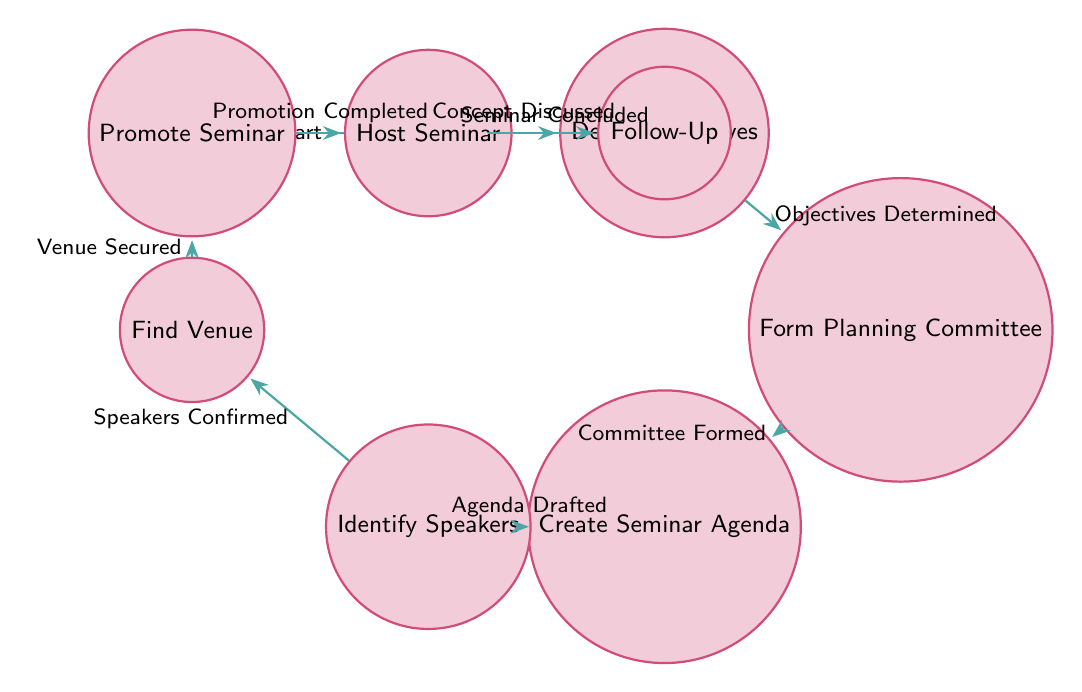What is the initial state of the diagram? The initial state in the diagram is labeled "Start." This is the starting point from which all other transitions occur to eventually organize the seminar.
Answer: Start How many states are there in total? By examining the diagram, I can count the nodes/states connected by edges. There are eight distinct states represented.
Answer: Eight What follows the "Define Objectives" state? Looking at the directed edge originating from "Define Objectives," the next state is "Form Planning Committee." The transition happens when the objectives are determined.
Answer: Form Planning Committee What triggers the transition from "Identify Speakers" to "Find Venue"? The edge between "Identify Speakers" and "Find Venue" indicates that the transition is triggered when speakers are confirmed. This shows a sequential relationship in planning the seminar.
Answer: Speakers Confirmed Which state do you reach after "Promote Seminar"? Following the edge that leads from "Promote Seminar," the next state is "Host Seminar." This indicates the progression from promoting the seminar to actually hosting it.
Answer: Host Seminar What is the last step in the process? The diagram shows that the last state is "Follow-Up," which occurs after the seminar concludes. This step involves gathering feedback and planning onward actions.
Answer: Follow-Up How many transitions are there in the diagram? Counting the directed edges between states, there are seven transitions that indicate the flow from one state to another as the seminar planning progresses.
Answer: Seven What is the relationship between "Create Seminar Agenda" and "Identify Speakers"? The diagram shows that "Create Seminar Agenda" leads to "Identify Speakers," signifying that an agenda must be drafted before reaching out to potential speakers.
Answer: Sequential relationship Which state is reached after "Host Seminar"? According to the flow of the diagram, after the state "Host Seminar," the next state is "Follow-Up." This shows that once the seminar is hosted, immediate follow-up actions are taken.
Answer: Follow-Up 